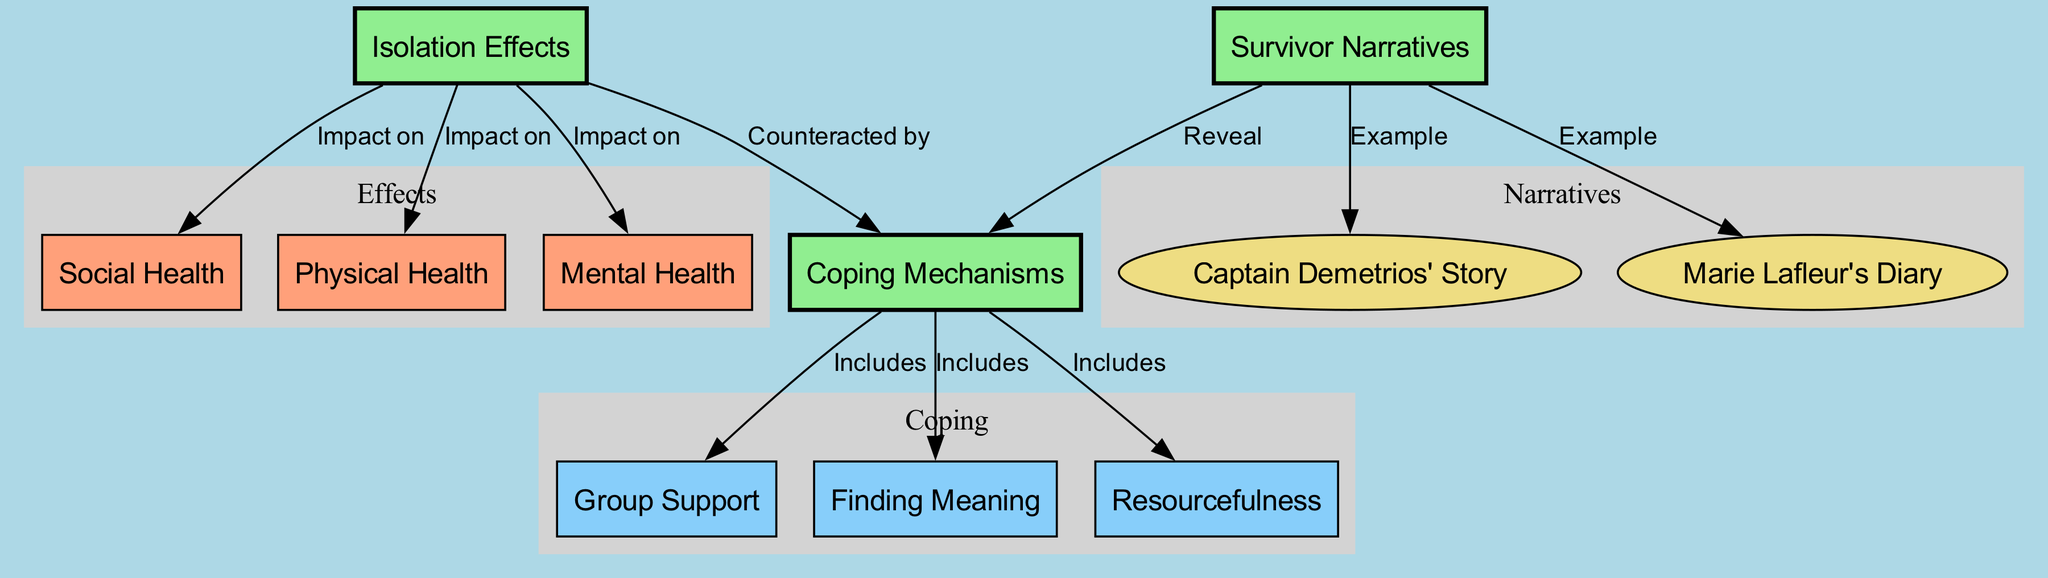What is the primary theme of the diagram? The primary theme of the diagram revolves around the "Psychological Effects of Shipwreck Isolation," encompassing various subtopics including isolation effects, survivor narratives, and coping mechanisms.
Answer: Psychological Effects of Shipwreck Isolation How many nodes are depicted in the diagram? Upon reviewing the diagram, we can count the nodes listed, which are 11 in total.
Answer: 11 Which narrative is specifically associated with Captain Demetrios? The diagram labels "Captain Demetrios' Story" under the node "Survivor Narratives," indicating its specific association.
Answer: Captain Demetrios' Story What are the three main areas impacted by isolation effects? The isolation effects impact three areas: physical health, mental health, and social health, as indicated by the links from the isolation effects node.
Answer: Physical Health, Mental Health, Social Health Which coping mechanism includes support from others? The diagram shows that "Group Support" is a coping mechanism included in the overall coping mechanisms category as indicated by their direct link.
Answer: Group Support What type of relationships are indicated by edges in the diagram? The edges in the diagram represent various relationships such as "Impact on," "Example," and "Includes," demonstrating how nodes connect and interact with one another.
Answer: Impact on, Example, Includes How do survivor narratives relate to coping mechanisms? The edges indicate that survivor narratives reveal coping mechanisms, meaning the information shared in these narratives provide insight into how survivors cope with their experiences.
Answer: Reveal Identify one example of a coping mechanism. The edges specify three coping mechanisms, one of which is "Finding Meaning," as shown in the diagram.
Answer: Finding Meaning What effect does shipwreck isolation have on mental health? The diagram illustrates that isolation effects have an "Impact on" mental health, emphasizing the psychological toll isolation can take during shipwreck experiences.
Answer: Impact on mental health What narrative is associated with a diary? The diagram clearly labels "Marie Lafleur's Diary" as one of the examples under the survivor narratives, which connects her experience to the theme.
Answer: Marie Lafleur's Diary 